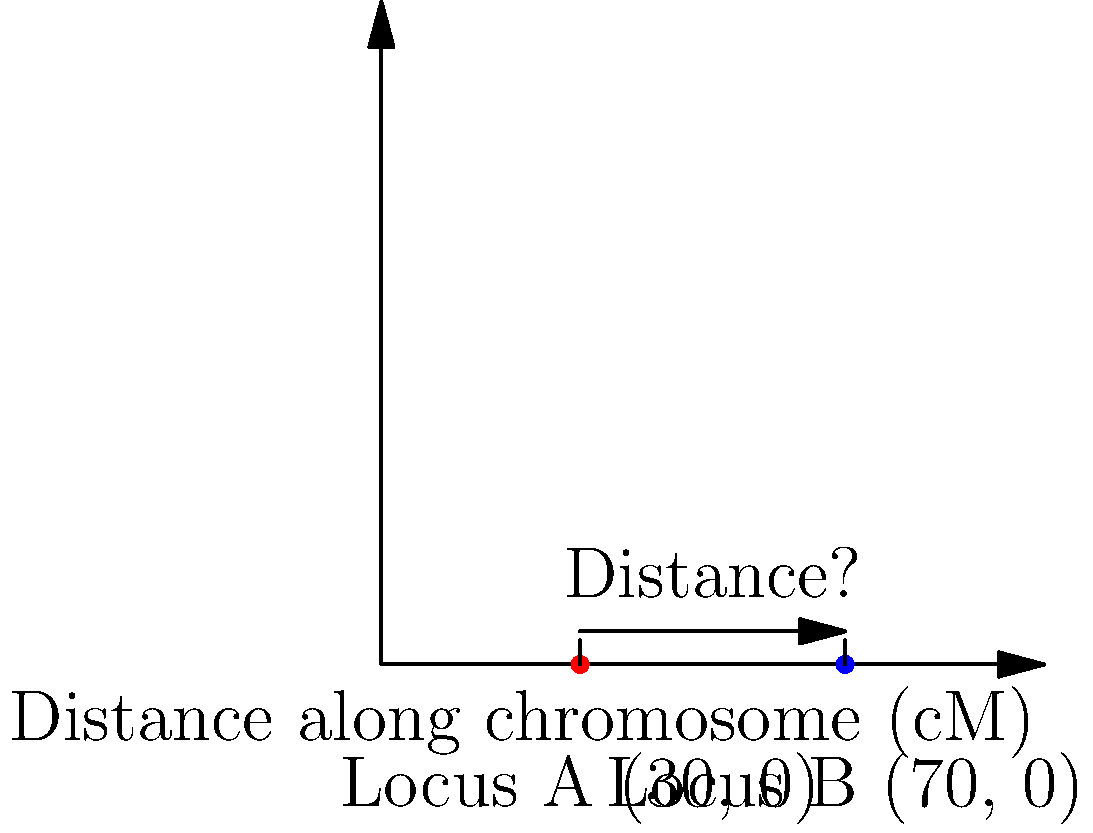In a genetic mapping study of sex determination genes, two loci (A and B) are found on the same chromosome. Using a genetic map where 1 centimorgan (cM) corresponds to 1 unit on the coordinate system, locus A is located at position (30, 0) and locus B at (70, 0). Calculate the genetic distance between these two loci in centimorgans (cM). To calculate the genetic distance between two loci on the same chromosome, we can use the distance formula in a one-dimensional case, since both loci are on the x-axis (y-coordinate is 0 for both).

The distance formula in one dimension is simply the absolute difference between the x-coordinates:

$$ \text{Distance} = |x_2 - x_1| $$

Where:
$x_1$ is the x-coordinate of locus A (30)
$x_2$ is the x-coordinate of locus B (70)

Plugging in the values:

$$ \text{Distance} = |70 - 30| = |40| = 40 $$

Since 1 unit on the coordinate system corresponds to 1 centimorgan (cM), the genetic distance between loci A and B is 40 cM.

This distance represents the recombination frequency between the two loci, indicating the likelihood of a crossover event occurring between them during meiosis. In genetic mapping, larger distances suggest a higher probability of recombination between genes, which is crucial information for understanding the organization and linkage of sex determination genes on the chromosome.
Answer: 40 cM 